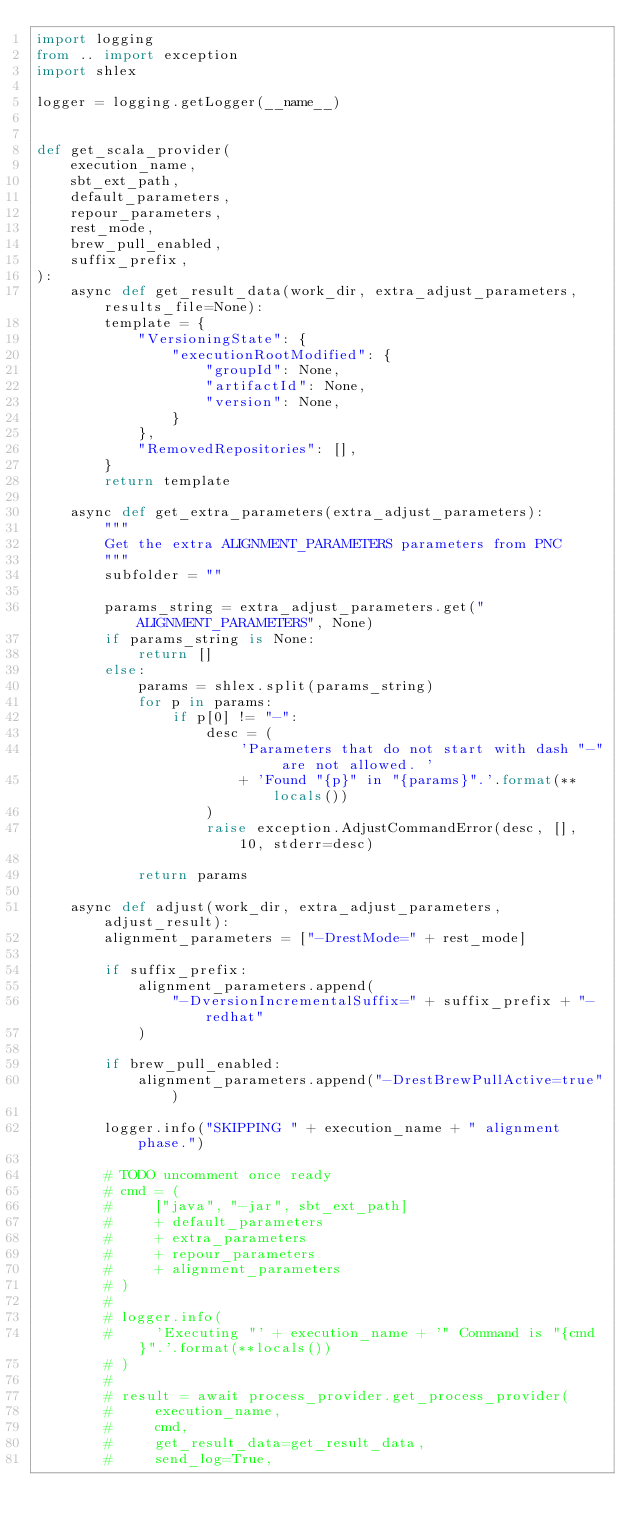<code> <loc_0><loc_0><loc_500><loc_500><_Python_>import logging
from .. import exception
import shlex

logger = logging.getLogger(__name__)


def get_scala_provider(
    execution_name,
    sbt_ext_path,
    default_parameters,
    repour_parameters,
    rest_mode,
    brew_pull_enabled,
    suffix_prefix,
):
    async def get_result_data(work_dir, extra_adjust_parameters, results_file=None):
        template = {
            "VersioningState": {
                "executionRootModified": {
                    "groupId": None,
                    "artifactId": None,
                    "version": None,
                }
            },
            "RemovedRepositories": [],
        }
        return template

    async def get_extra_parameters(extra_adjust_parameters):
        """
        Get the extra ALIGNMENT_PARAMETERS parameters from PNC
        """
        subfolder = ""

        params_string = extra_adjust_parameters.get("ALIGNMENT_PARAMETERS", None)
        if params_string is None:
            return []
        else:
            params = shlex.split(params_string)
            for p in params:
                if p[0] != "-":
                    desc = (
                        'Parameters that do not start with dash "-" are not allowed. '
                        + 'Found "{p}" in "{params}".'.format(**locals())
                    )
                    raise exception.AdjustCommandError(desc, [], 10, stderr=desc)

            return params

    async def adjust(work_dir, extra_adjust_parameters, adjust_result):
        alignment_parameters = ["-DrestMode=" + rest_mode]

        if suffix_prefix:
            alignment_parameters.append(
                "-DversionIncrementalSuffix=" + suffix_prefix + "-redhat"
            )

        if brew_pull_enabled:
            alignment_parameters.append("-DrestBrewPullActive=true")

        logger.info("SKIPPING " + execution_name + " alignment phase.")

        # TODO uncomment once ready
        # cmd = (
        #     ["java", "-jar", sbt_ext_path]
        #     + default_parameters
        #     + extra_parameters
        #     + repour_parameters
        #     + alignment_parameters
        # )
        #
        # logger.info(
        #     'Executing "' + execution_name + '" Command is "{cmd}".'.format(**locals())
        # )
        #
        # result = await process_provider.get_process_provider(
        #     execution_name,
        #     cmd,
        #     get_result_data=get_result_data,
        #     send_log=True,</code> 